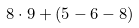<formula> <loc_0><loc_0><loc_500><loc_500>8 \cdot 9 + ( 5 - 6 - 8 )</formula> 